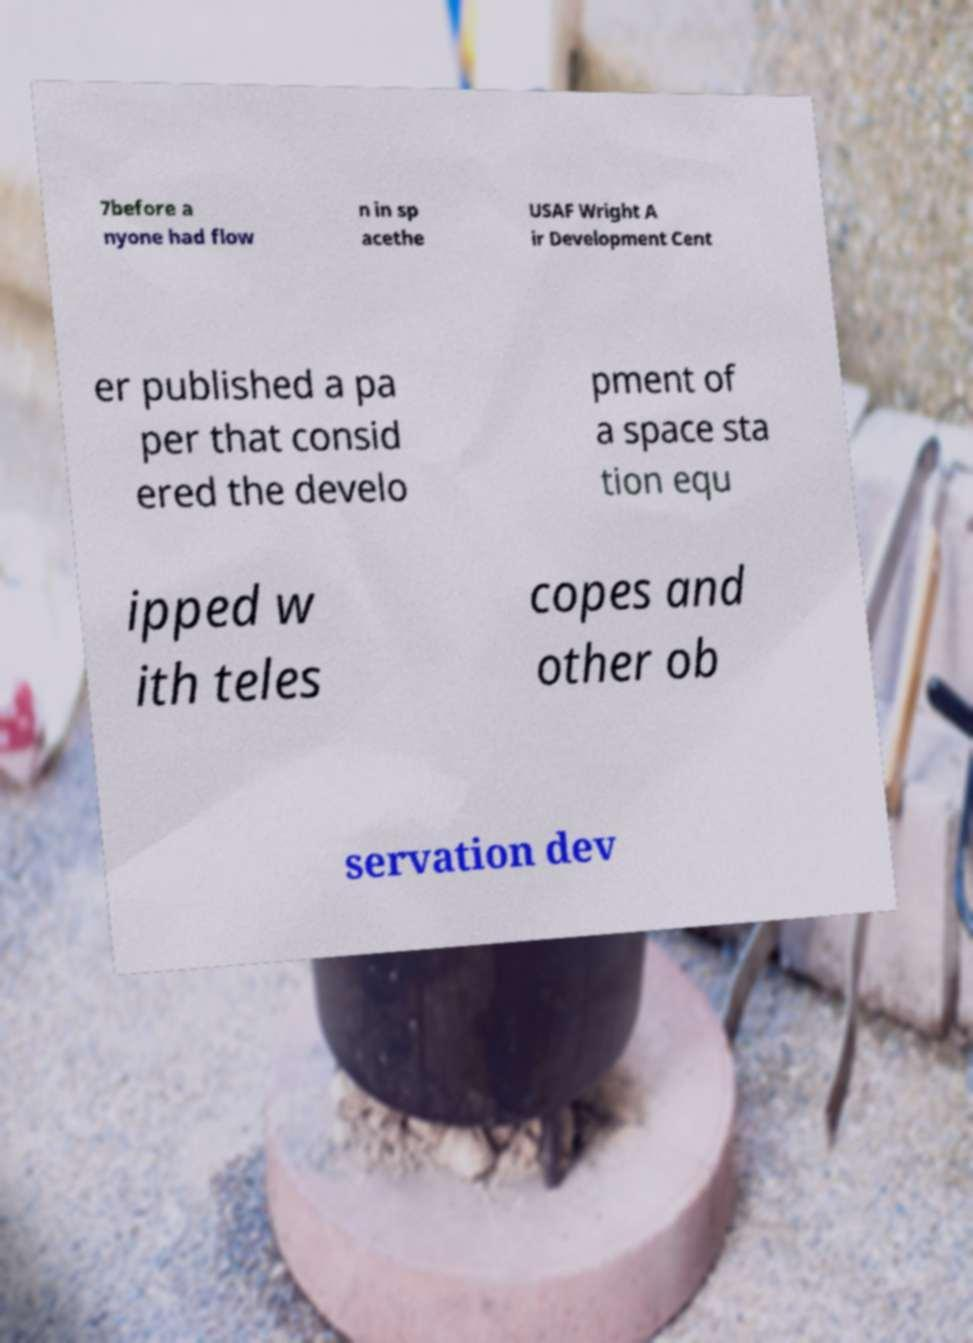Can you read and provide the text displayed in the image?This photo seems to have some interesting text. Can you extract and type it out for me? 7before a nyone had flow n in sp acethe USAF Wright A ir Development Cent er published a pa per that consid ered the develo pment of a space sta tion equ ipped w ith teles copes and other ob servation dev 